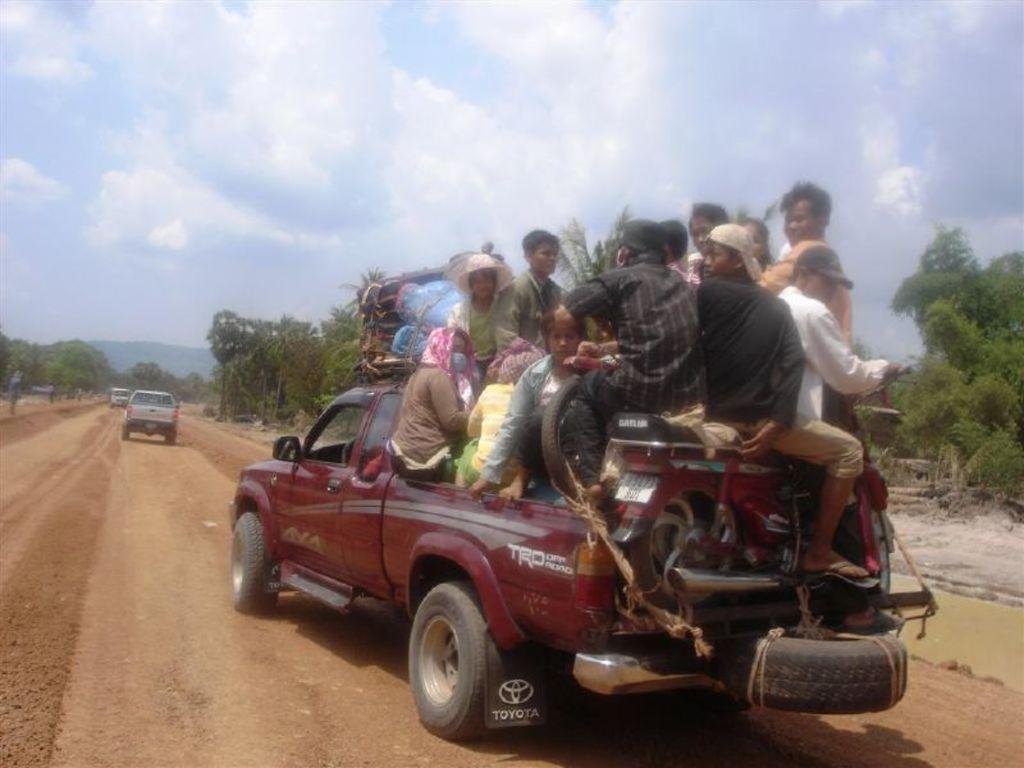What is happening in the image? There are persons inside a vehicle in the image. What can be seen in the background of the image? There are trees and the sky visible in the background of the image. What is the condition of the sky in the image? The sky has heavy clouds in the image. What else is present on the road besides the vehicle? There are cars on the road in the image. What type of plantation can be seen in the background of the image? There is no plantation present in the image; it shows a road with trees in the background. What is the jelly used for in the image? There is no jelly present in the image. 